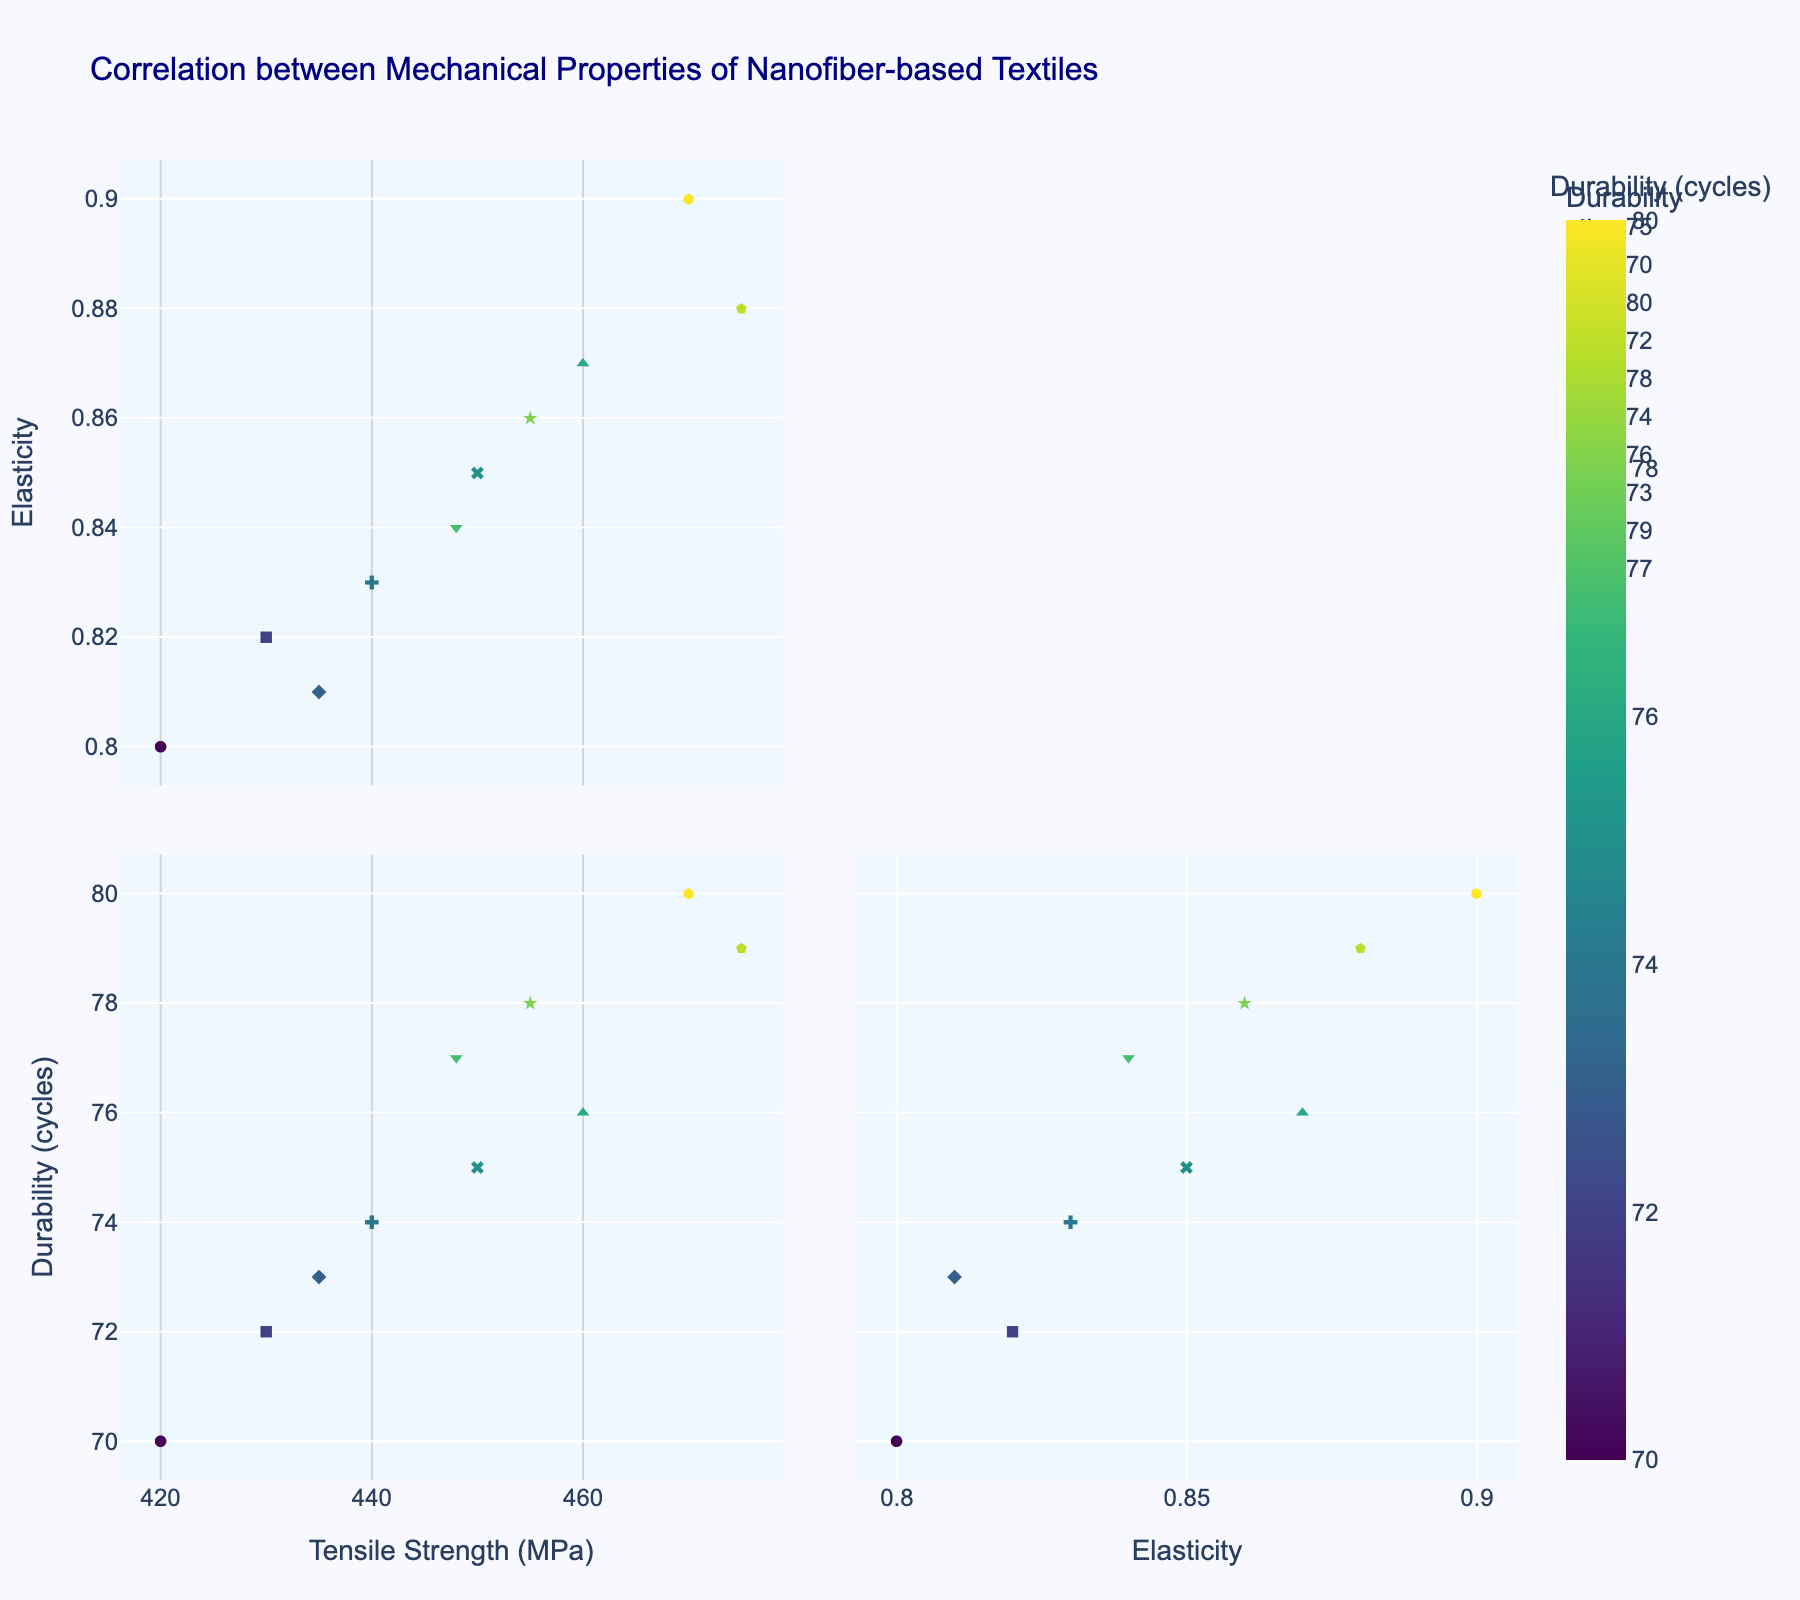What is the title of the figure? The title of the figure is usually displayed at the top of the plot. By looking at the figure, we see the title "Correlation between Mechanical Properties of Nanofiber-based Textiles."
Answer: Correlation between Mechanical Properties of Nanofiber-based Textiles How many different dimensions are visualized in the SPLOM? The scatter plot matrix (SPLOM) uses several scatter plots to show pairwise relationships between multiple dimensions. By examining the axes and labels, we see three dimensions: tensile strength, elasticity, and durability.
Answer: 3 What color scale is used to indicate durability? The scatter plot matrix uses a specific color scale to represent durability. In this case, the 'Viridis' color scale is used to color the data points according to their durability values.
Answer: Viridis What is the shape used for data points with a durability of 72 cycles? Each durability value is represented by a unique symbol. By looking at the legend, we see that a durability of 72 is symbolized by a square.
Answer: square In the scatter plot comparing tensile strength and elasticity, what general trend do you observe? To determine the trend, we need to look at the scatter plot that compares tensile strength and elasticity. As tensile strength increases, elasticity also tends to increase, suggesting a positive correlation.
Answer: positive correlation Between tensile strength and elasticity, which property exhibits a wider range of values? To find this, we examine the axis ranges of the scatter plots. Tensile strength varies between approximately 420 and 475 MPa, while elasticity ranges from approximately 0.80 to 0.90. Therefore, tensile strength has a wider range.
Answer: tensile strength Which two properties show the weakest correlation? Judging by the density and spread of data points in the SPLOM, the plot with the most scattered points shows the weakest correlation. This is the plot comparing elasticity and durability, where the points are not clustered along a clear line.
Answer: elasticity and durability What is the median tensile strength among the data points? To find the median tensile strength, we sort the tensile strength values and find the middle number. The sorted tensile strengths are: 420, 430, 435, 440, 448, 450, 455, 460, 470, 475. The median is the average of the 5th and 6th values: (448 + 450) / 2 = 449.
Answer: 449 For a textile with an elasticity of 0.85, what can be inferred about its durability and tensile strength? Data points with an elasticity of 0.85 could be located by finding corresponding points on the elasticity axis. By inspecting these points, we find a durability of 75 and tensile strength of 450 MPa.
Answer: durability: 75, tensile strength: 450 Which data point has the highest tensile strength and what are its corresponding elasticity and durability values? By identifying the data point with the highest tensile strength in the scatter plots, we observe that it has a tensile strength of 475 MPa. The corresponding elasticity is 0.88 and the durability is 79 cycles.
Answer: elasticity: 0.88, durability: 79 